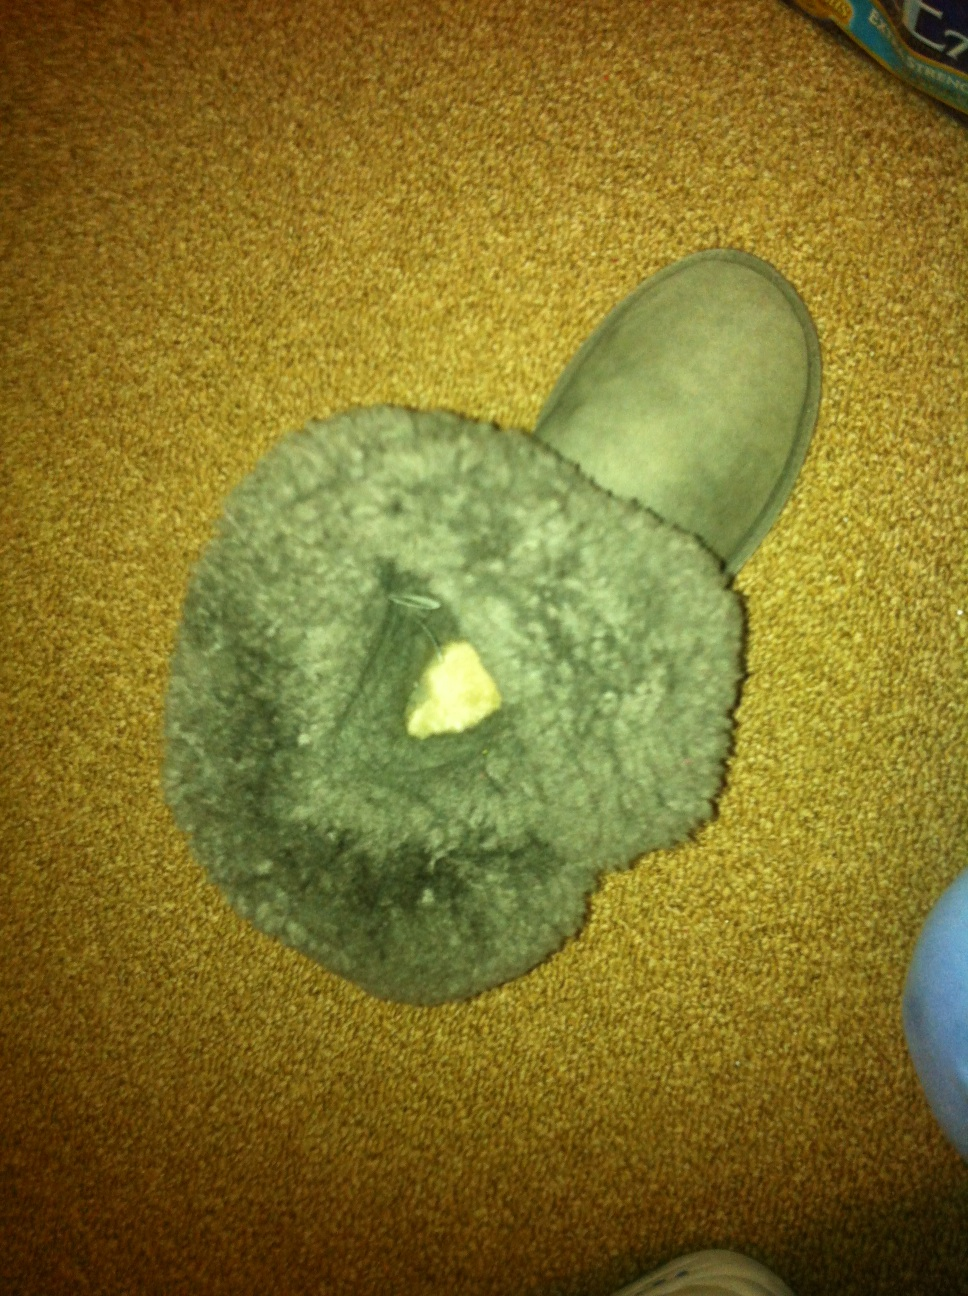Imagine this boot in a historical context. What role or significance might it have had? In a historical context, a boot like this might have been worn by travelers or traders during long journeys. Its durable construction and warm, fur-lined interior would be perfect for protecting one’s feet from the cold and harsh conditions. Such boots could have been significant in historical trade routes, like the Silk Road, where enduring long travels through varied weather conditions were crucial for the traders' success. They might also have been popular among soldiers stationed in cold, mountainous regions, providing essential protection and comfort during their demanding duties. 